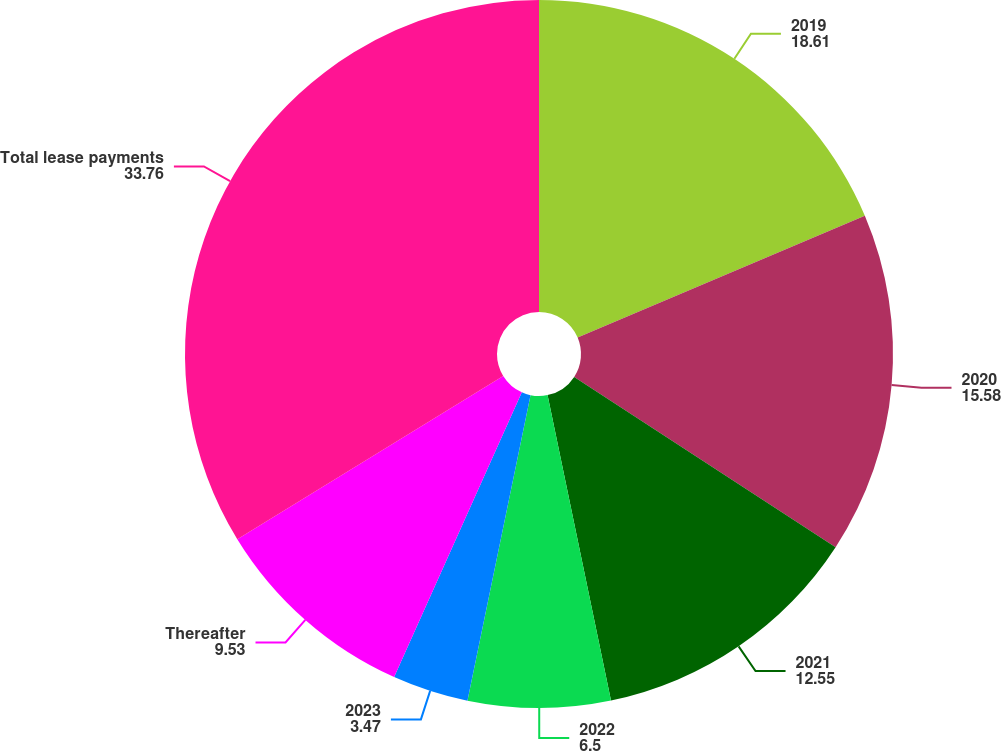Convert chart. <chart><loc_0><loc_0><loc_500><loc_500><pie_chart><fcel>2019<fcel>2020<fcel>2021<fcel>2022<fcel>2023<fcel>Thereafter<fcel>Total lease payments<nl><fcel>18.61%<fcel>15.58%<fcel>12.55%<fcel>6.5%<fcel>3.47%<fcel>9.53%<fcel>33.76%<nl></chart> 